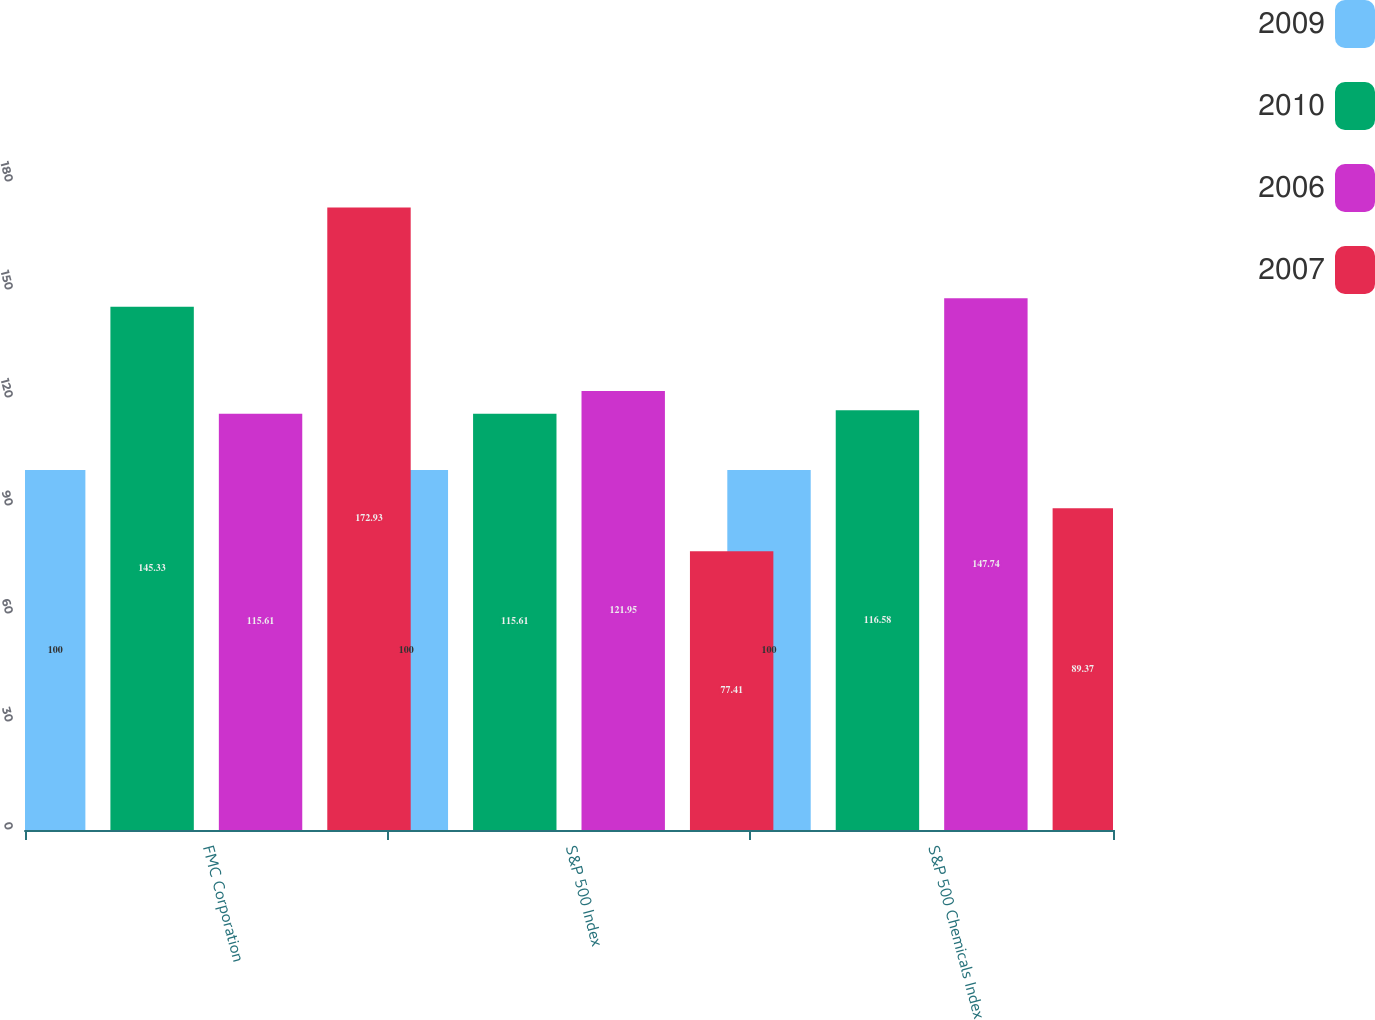Convert chart. <chart><loc_0><loc_0><loc_500><loc_500><stacked_bar_chart><ecel><fcel>FMC Corporation<fcel>S&P 500 Index<fcel>S&P 500 Chemicals Index<nl><fcel>2009<fcel>100<fcel>100<fcel>100<nl><fcel>2010<fcel>145.33<fcel>115.61<fcel>116.58<nl><fcel>2006<fcel>115.61<fcel>121.95<fcel>147.74<nl><fcel>2007<fcel>172.93<fcel>77.41<fcel>89.37<nl></chart> 